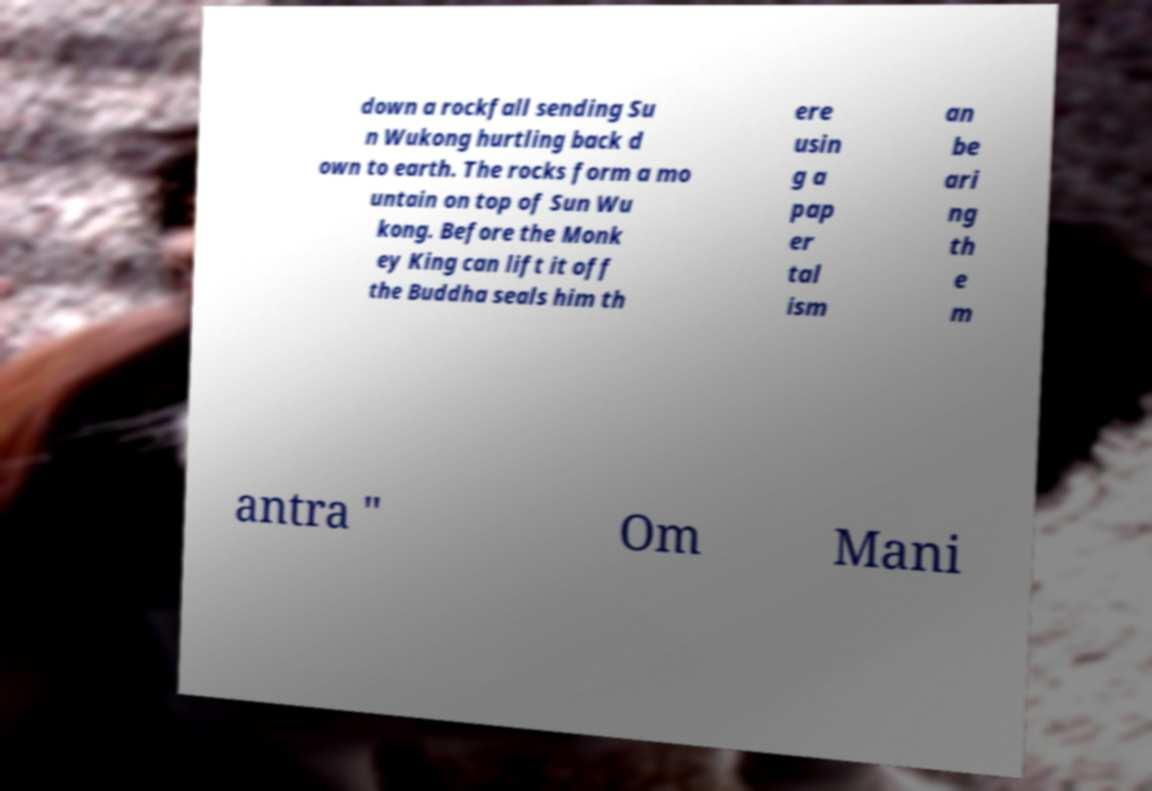There's text embedded in this image that I need extracted. Can you transcribe it verbatim? down a rockfall sending Su n Wukong hurtling back d own to earth. The rocks form a mo untain on top of Sun Wu kong. Before the Monk ey King can lift it off the Buddha seals him th ere usin g a pap er tal ism an be ari ng th e m antra " Om Mani 